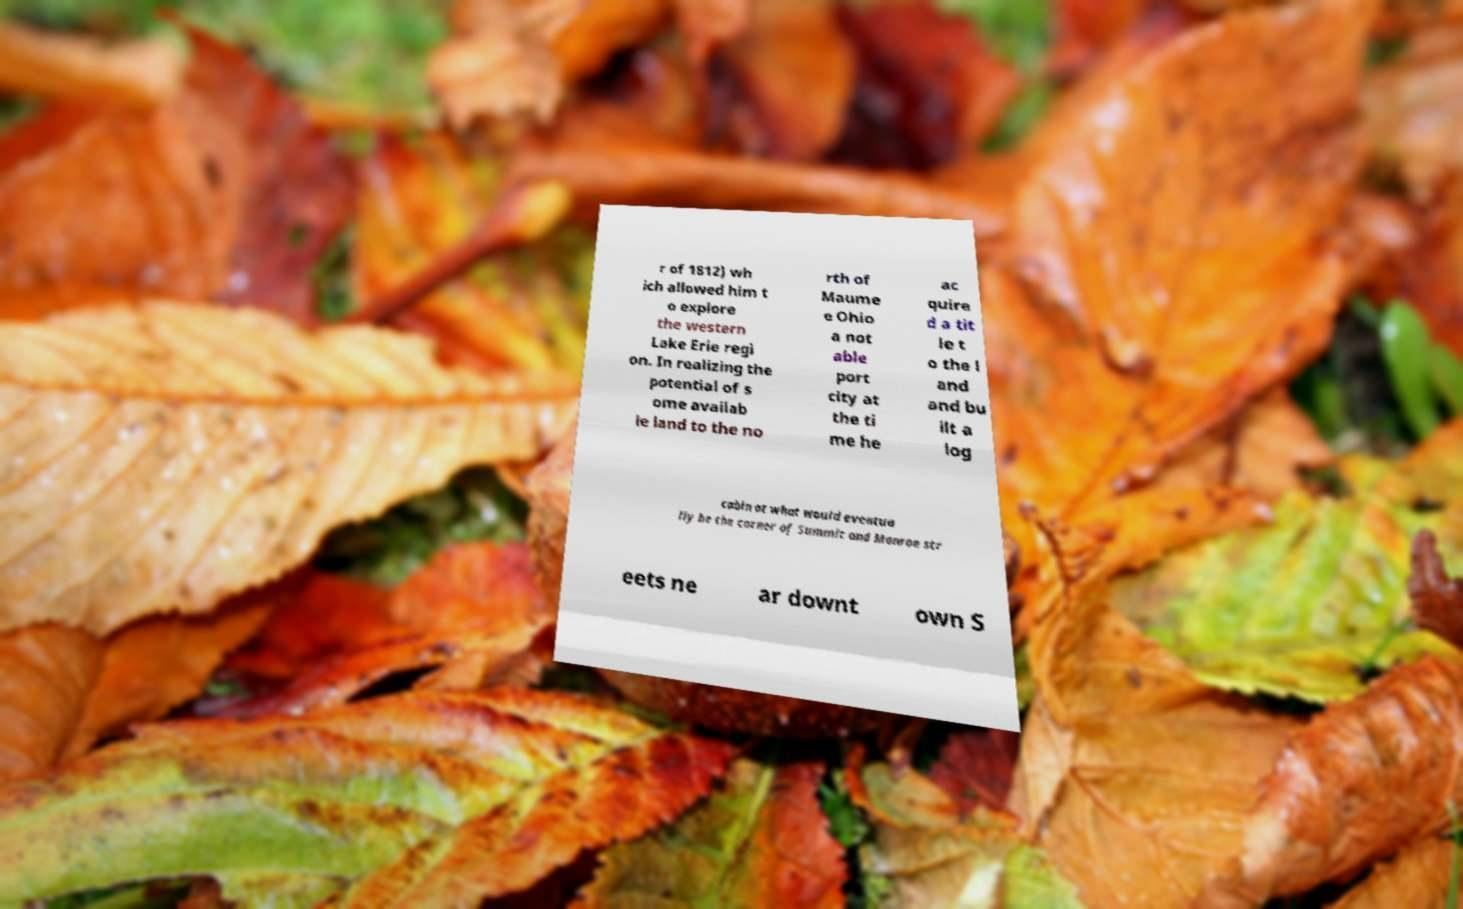Could you extract and type out the text from this image? r of 1812) wh ich allowed him t o explore the western Lake Erie regi on. In realizing the potential of s ome availab le land to the no rth of Maume e Ohio a not able port city at the ti me he ac quire d a tit le t o the l and and bu ilt a log cabin at what would eventua lly be the corner of Summit and Monroe str eets ne ar downt own S 